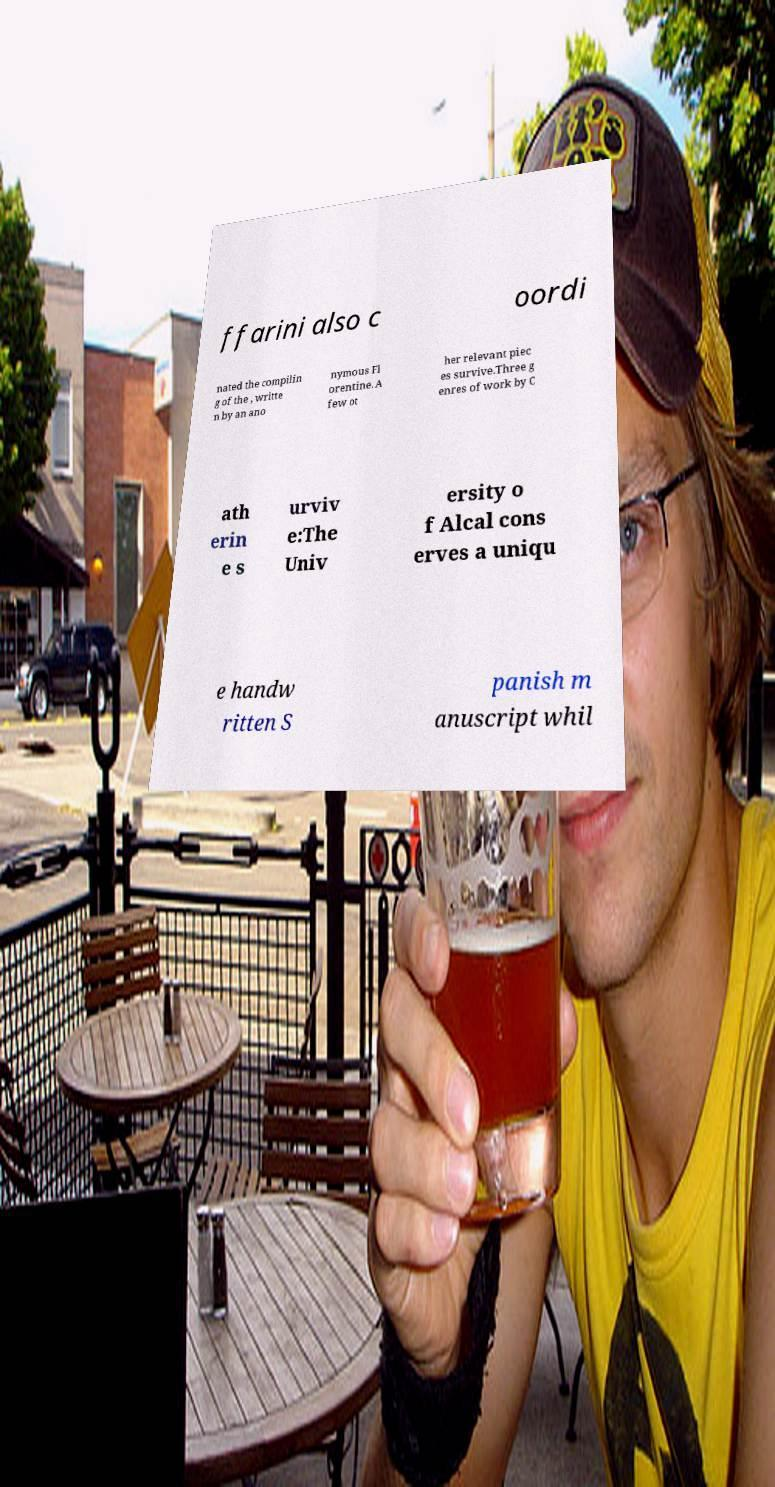There's text embedded in this image that I need extracted. Can you transcribe it verbatim? ffarini also c oordi nated the compilin g of the , writte n by an ano nymous Fl orentine. A few ot her relevant piec es survive.Three g enres of work by C ath erin e s urviv e:The Univ ersity o f Alcal cons erves a uniqu e handw ritten S panish m anuscript whil 